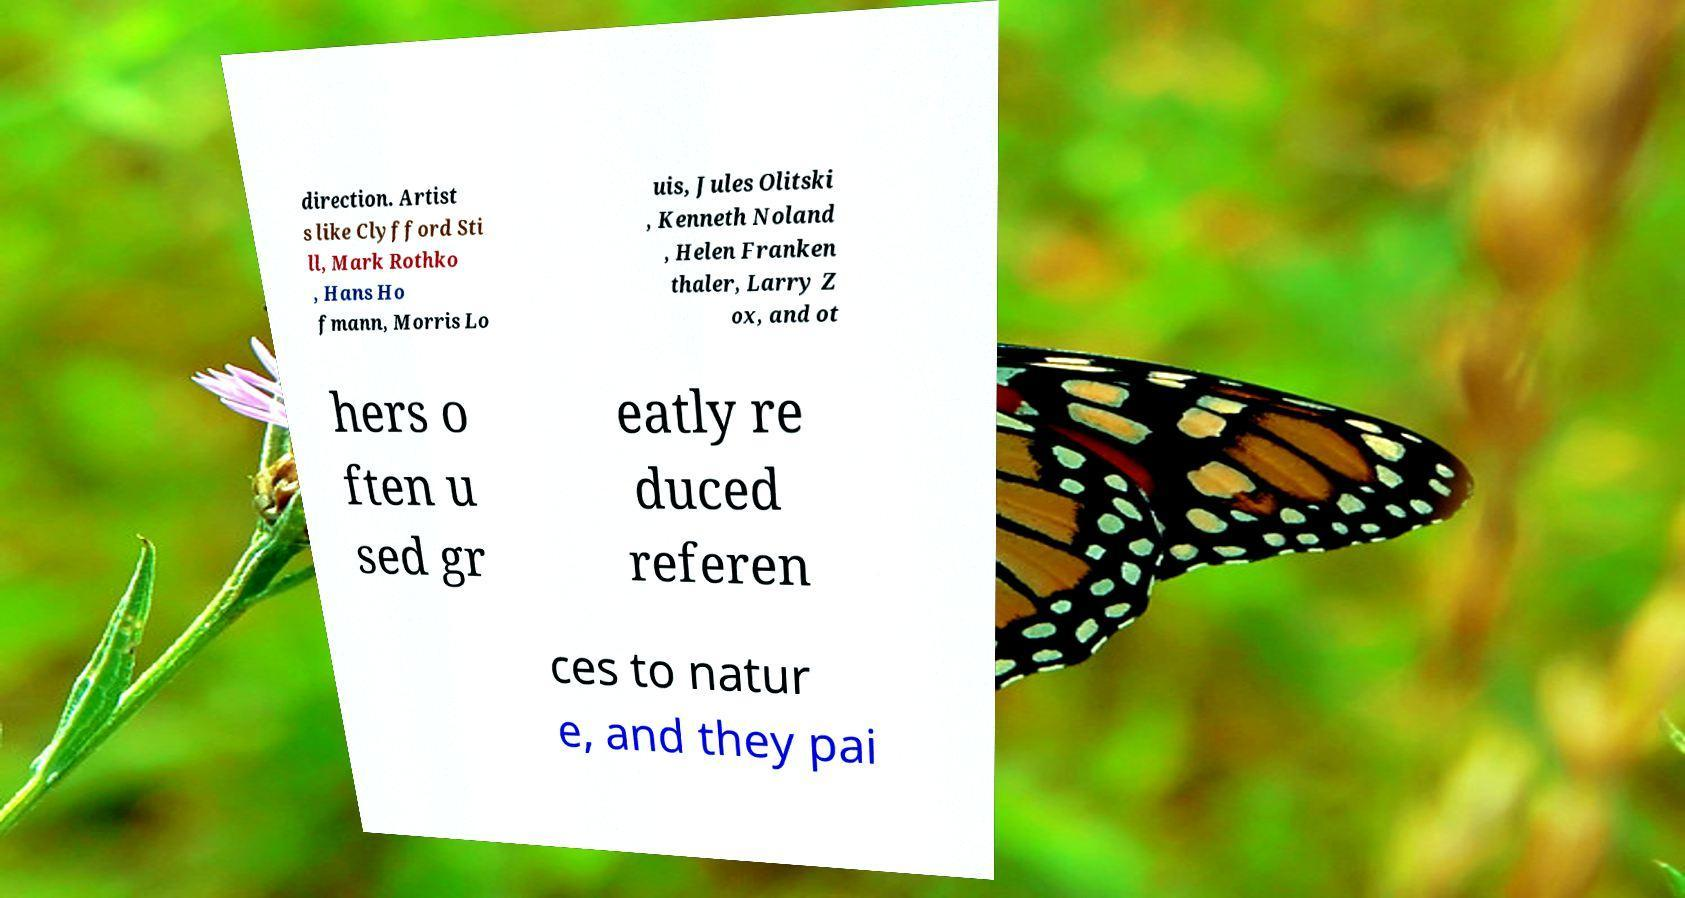Please identify and transcribe the text found in this image. direction. Artist s like Clyfford Sti ll, Mark Rothko , Hans Ho fmann, Morris Lo uis, Jules Olitski , Kenneth Noland , Helen Franken thaler, Larry Z ox, and ot hers o ften u sed gr eatly re duced referen ces to natur e, and they pai 